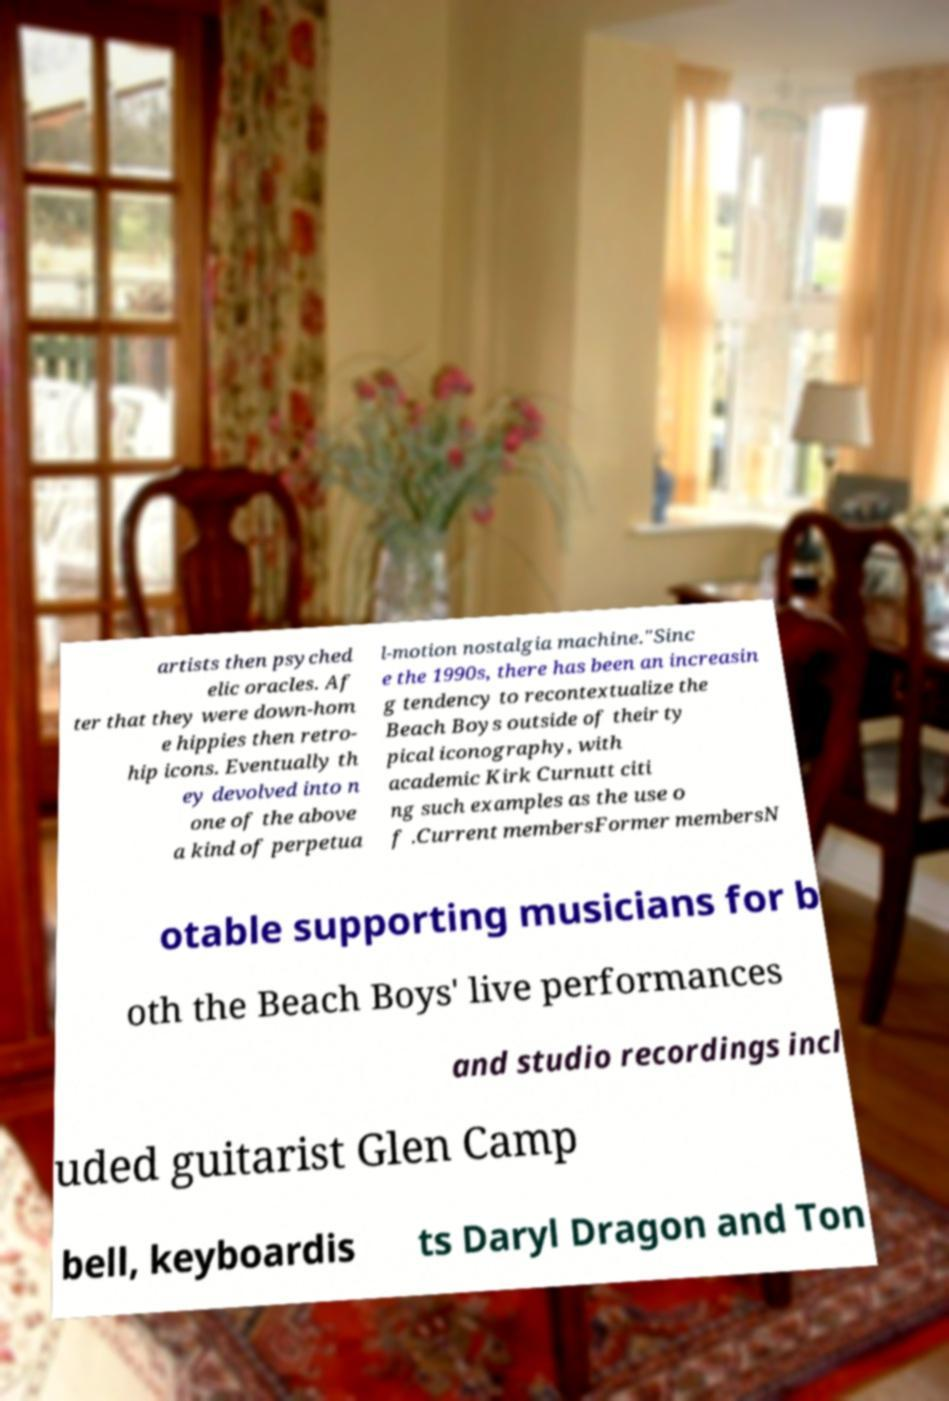Can you read and provide the text displayed in the image?This photo seems to have some interesting text. Can you extract and type it out for me? artists then psyched elic oracles. Af ter that they were down-hom e hippies then retro- hip icons. Eventually th ey devolved into n one of the above a kind of perpetua l-motion nostalgia machine."Sinc e the 1990s, there has been an increasin g tendency to recontextualize the Beach Boys outside of their ty pical iconography, with academic Kirk Curnutt citi ng such examples as the use o f .Current membersFormer membersN otable supporting musicians for b oth the Beach Boys' live performances and studio recordings incl uded guitarist Glen Camp bell, keyboardis ts Daryl Dragon and Ton 